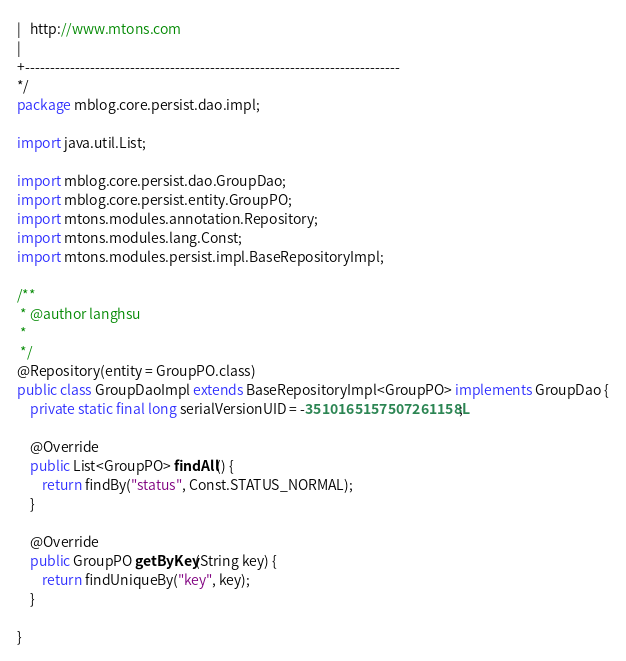Convert code to text. <code><loc_0><loc_0><loc_500><loc_500><_Java_>|   http://www.mtons.com
|
+---------------------------------------------------------------------------
*/
package mblog.core.persist.dao.impl;

import java.util.List;

import mblog.core.persist.dao.GroupDao;
import mblog.core.persist.entity.GroupPO;
import mtons.modules.annotation.Repository;
import mtons.modules.lang.Const;
import mtons.modules.persist.impl.BaseRepositoryImpl;

/**
 * @author langhsu
 *
 */
@Repository(entity = GroupPO.class)
public class GroupDaoImpl extends BaseRepositoryImpl<GroupPO> implements GroupDao {
	private static final long serialVersionUID = -3510165157507261158L;

	@Override
	public List<GroupPO> findAll() {
		return findBy("status", Const.STATUS_NORMAL);
	}

	@Override
	public GroupPO getByKey(String key) {
		return findUniqueBy("key", key);
	}

}
</code> 